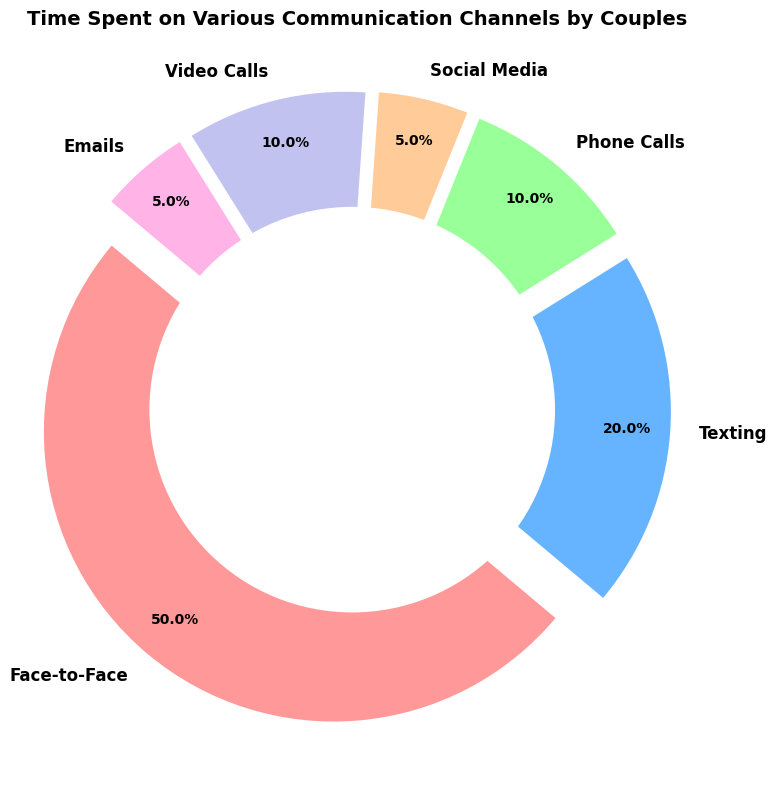What's the total percentage of time spent on asynchronous communication channels? Asynchronous communication channels are those where there is no expectation of an immediate response. In this chart, the relevant channels are Texting, Social Media, and Emails. Sum their percentages: Texting (20%) + Social Media (5%) + Emails (5%) = 30%.
Answer: 30% Which communication channel do couples spend the most time on? From the chart, the largest section is labeled "Face-to-Face", which also shows the highest percentage at 50%.
Answer: Face-to-Face How does the combined percentage of time spent on Video Calls and Phone Calls compare to the time spent on Texting? Sum the percentages of Video Calls (10%) and Phone Calls (10%), which gives 20%. Compare this with the percentage spent on Texting, which is also 20%. They are equal.
Answer: Equal Which communication channels are tied for the least amount of time spent? From the chart, the smallest sections are Social Media and Emails, both showing 5%.
Answer: Social Media and Emails What's the percentage difference between the time spent on Face-to-Face communication and the total time spent on all other channels combined? Face-to-Face time is 50%. Total time spent on other channels is Texting (20%) + Phone Calls (10%) + Social Media (5%) + Video Calls (10%) + Emails (5%) = 50%. The difference is 50% - 50% = 0%.
Answer: 0% What percentage of time do couples spend on synchronous communication channels? Synchronous communication channels are those where interactions happen in real-time. Relevant channels are Face-to-Face, Phone Calls, and Video Calls. Sum their percentages: Face-to-Face (50%) + Phone Calls (10%) + Video Calls (10%) = 70%.
Answer: 70% Which communication channel occupies the second-largest portion of time? From the chart, the section labeled "Texting" is the second-largest with 20%.
Answer: Texting How does the time spent on Phone Calls compare to the combined time spent on Social Media and Emails? Phone Calls take up 10%. Combined time for Social Media and Emails is 5% + 5% = 10%. They are equal.
Answer: Equal What is the average percentage of time spent on each communication channel? There are six communication channels, each with respective times: 50%, 20%, 10%, 5%, 10%, and 5%. Summing these gives 100%. The average is 100% / 6 ≈ 16.67%.
Answer: 16.67% 